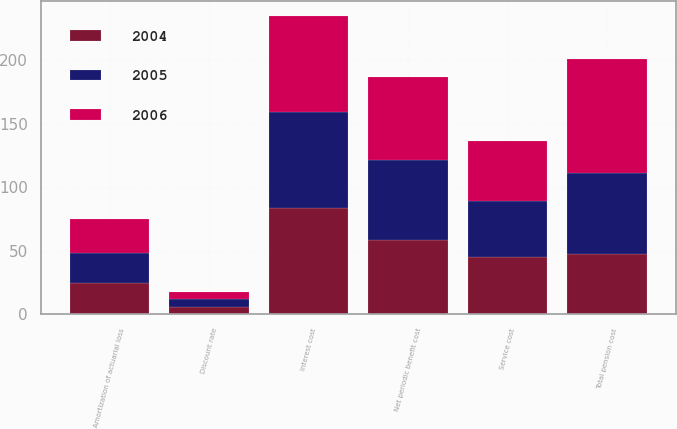Convert chart. <chart><loc_0><loc_0><loc_500><loc_500><stacked_bar_chart><ecel><fcel>Service cost<fcel>Interest cost<fcel>Amortization of actuarial loss<fcel>Net periodic benefit cost<fcel>Total pension cost<fcel>Discount rate<nl><fcel>2004<fcel>45.2<fcel>83.4<fcel>24.4<fcel>58.2<fcel>47.4<fcel>5.5<nl><fcel>2006<fcel>47.4<fcel>76.1<fcel>26.6<fcel>64.9<fcel>90.5<fcel>5.75<nl><fcel>2005<fcel>43.8<fcel>75.7<fcel>24.2<fcel>63.6<fcel>63.6<fcel>6.25<nl></chart> 